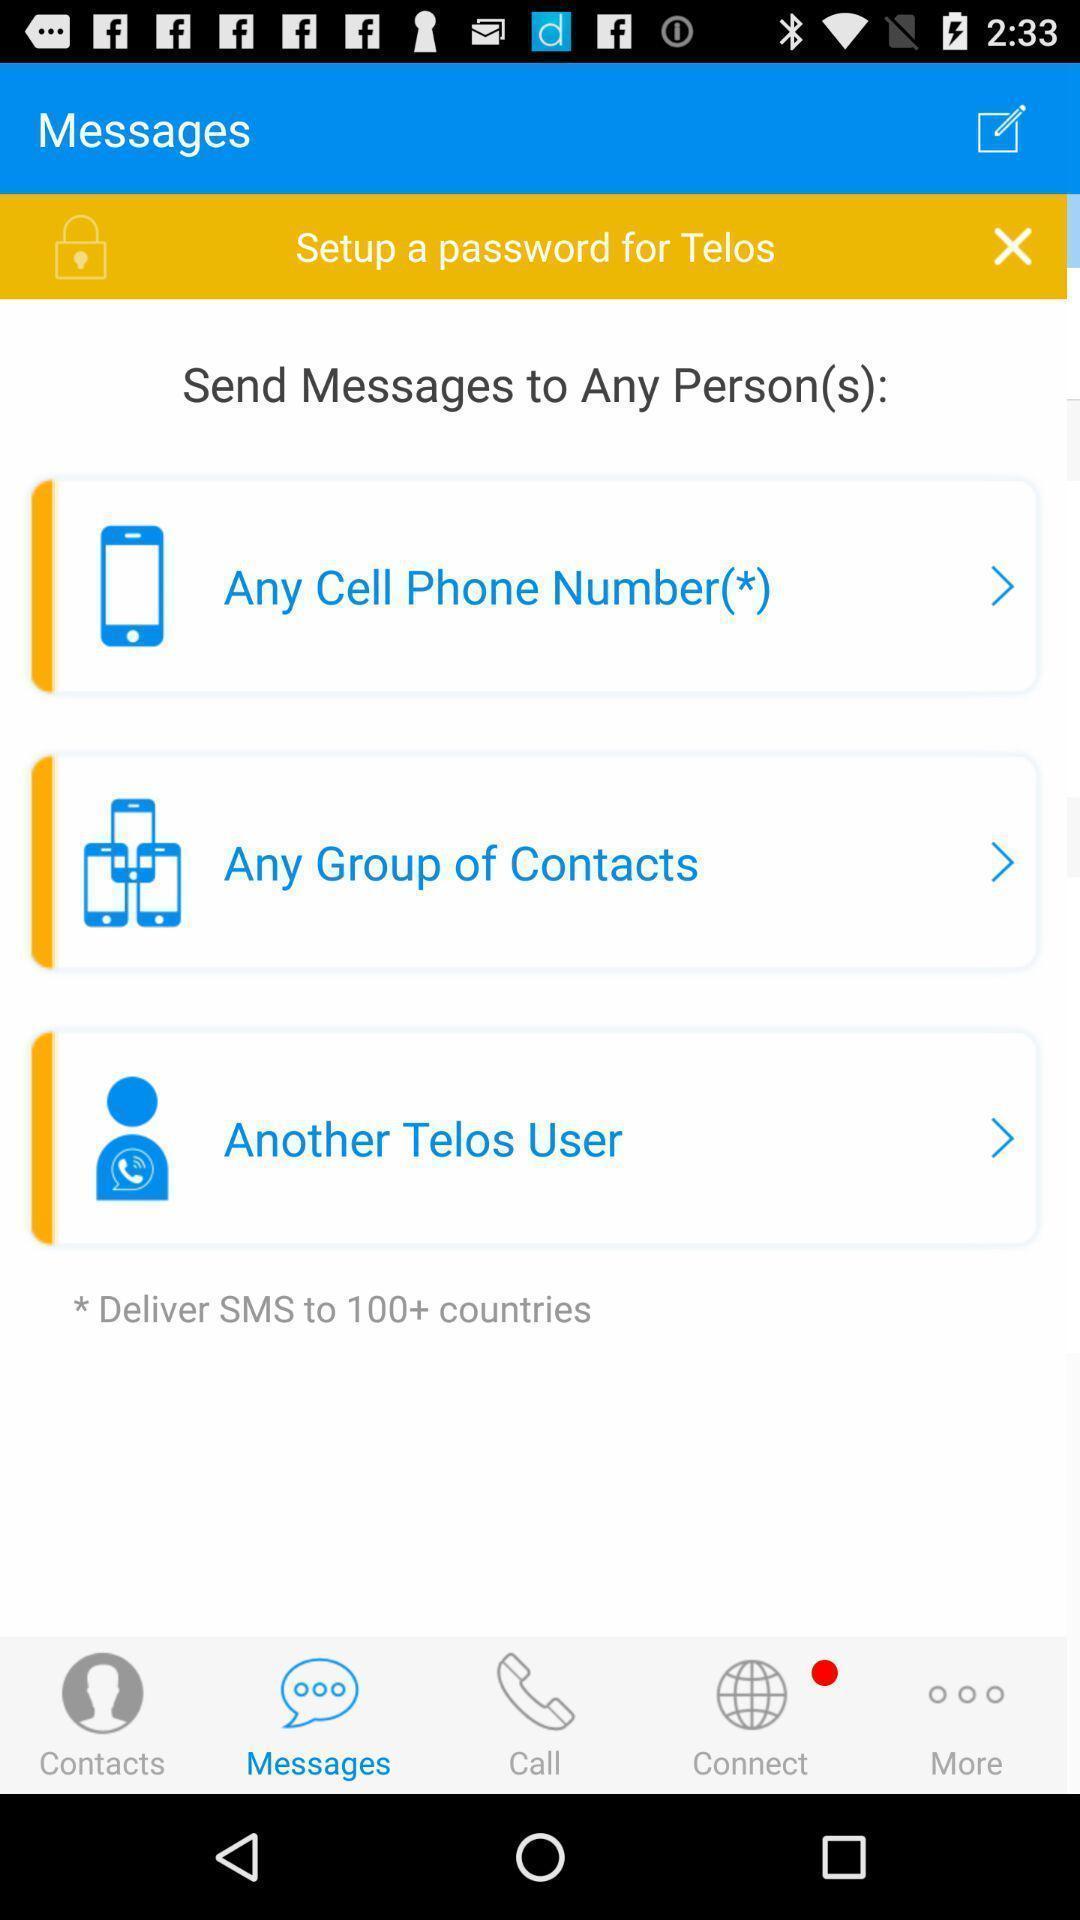Tell me about the visual elements in this screen capture. Screen shows different options for messages. 